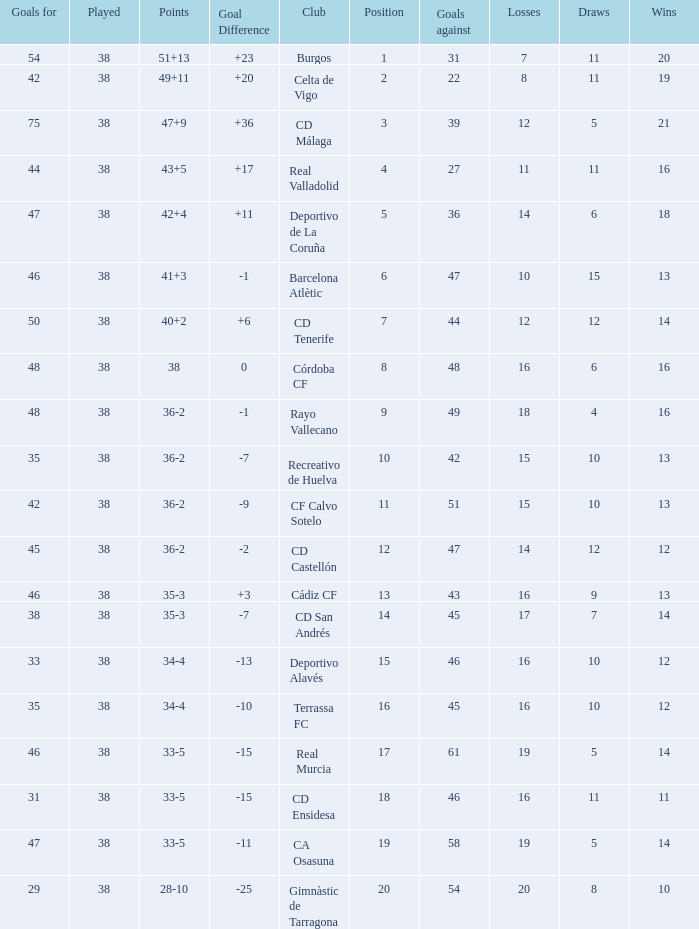What is the average loss with a goal higher than 51 and wins higher than 14? None. 